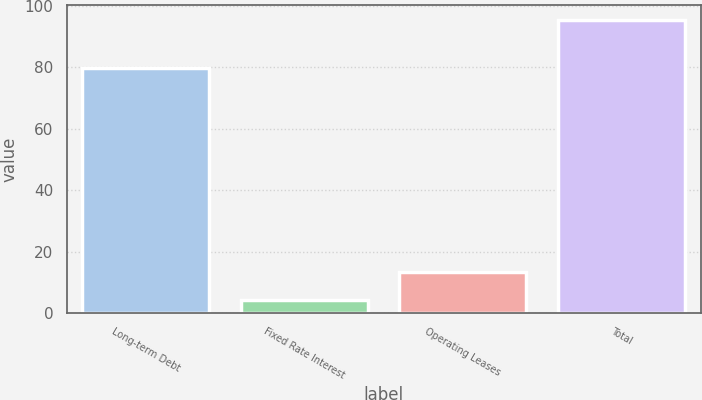<chart> <loc_0><loc_0><loc_500><loc_500><bar_chart><fcel>Long-term Debt<fcel>Fixed Rate Interest<fcel>Operating Leases<fcel>Total<nl><fcel>79.9<fcel>4.3<fcel>13.41<fcel>95.4<nl></chart> 